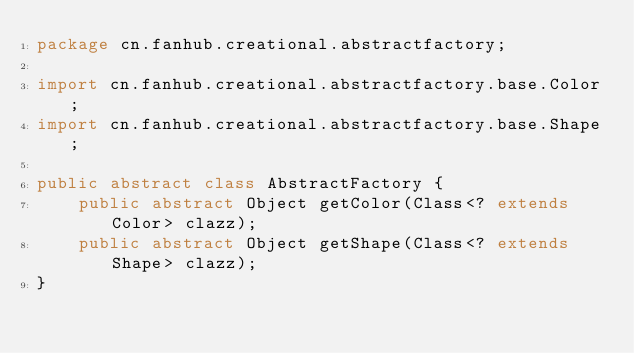Convert code to text. <code><loc_0><loc_0><loc_500><loc_500><_Java_>package cn.fanhub.creational.abstractfactory;

import cn.fanhub.creational.abstractfactory.base.Color;
import cn.fanhub.creational.abstractfactory.base.Shape;

public abstract class AbstractFactory {
    public abstract Object getColor(Class<? extends Color> clazz);
    public abstract Object getShape(Class<? extends Shape> clazz);
}</code> 